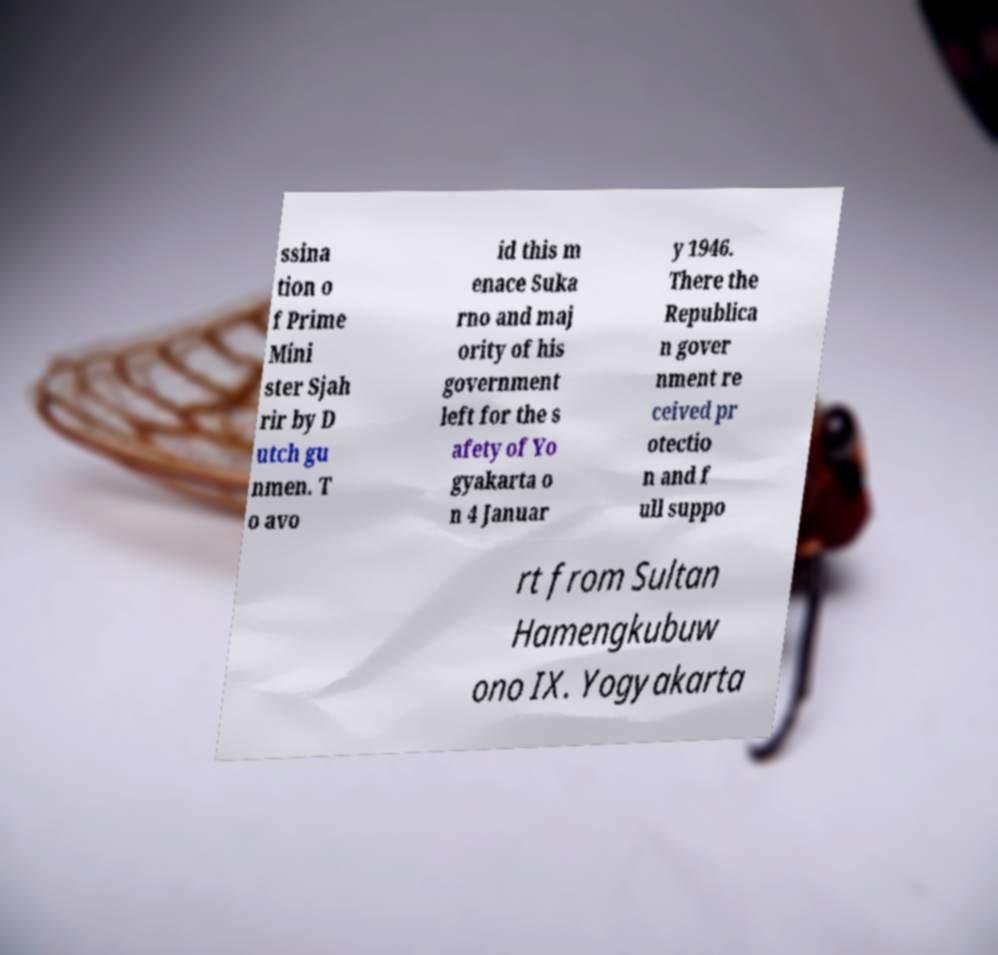For documentation purposes, I need the text within this image transcribed. Could you provide that? ssina tion o f Prime Mini ster Sjah rir by D utch gu nmen. T o avo id this m enace Suka rno and maj ority of his government left for the s afety of Yo gyakarta o n 4 Januar y 1946. There the Republica n gover nment re ceived pr otectio n and f ull suppo rt from Sultan Hamengkubuw ono IX. Yogyakarta 